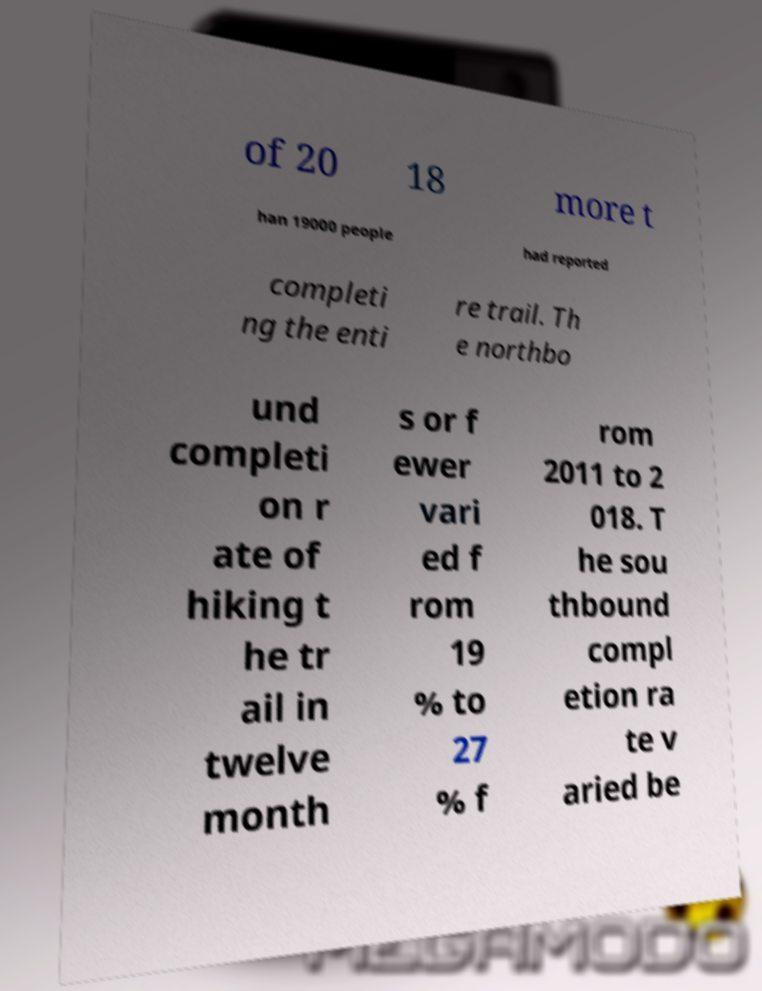I need the written content from this picture converted into text. Can you do that? of 20 18 more t han 19000 people had reported completi ng the enti re trail. Th e northbo und completi on r ate of hiking t he tr ail in twelve month s or f ewer vari ed f rom 19 % to 27 % f rom 2011 to 2 018. T he sou thbound compl etion ra te v aried be 